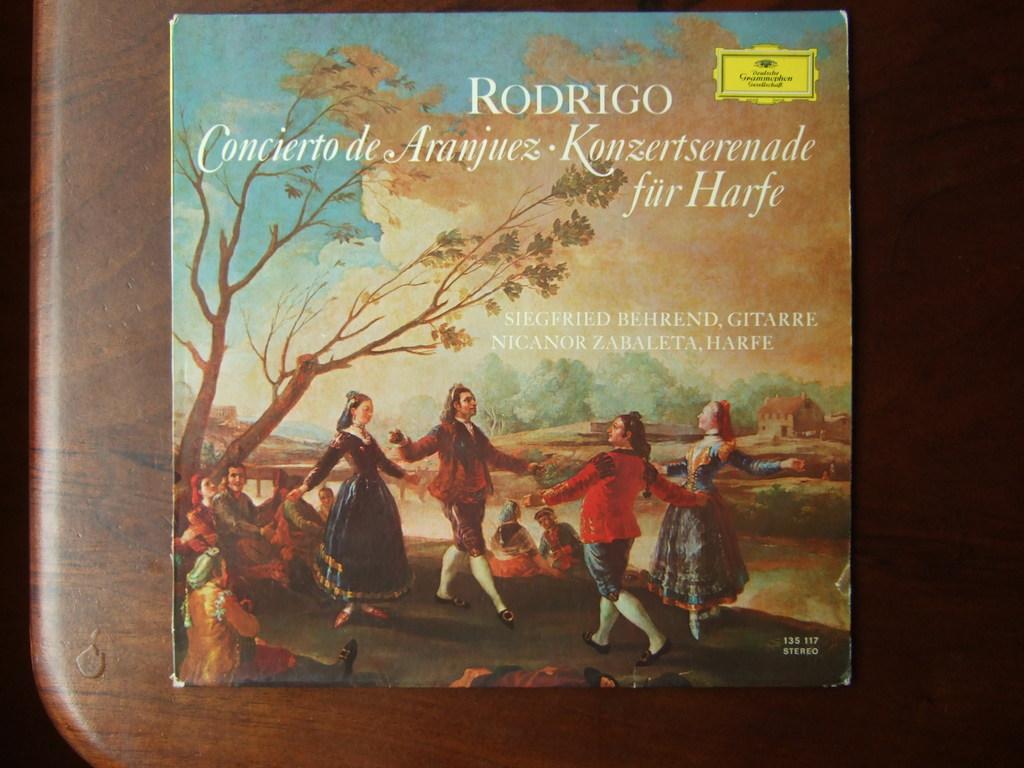What is one of the names on this paper?
Give a very brief answer. Rodrigo. Is this a stereo album?
Keep it short and to the point. Yes. 